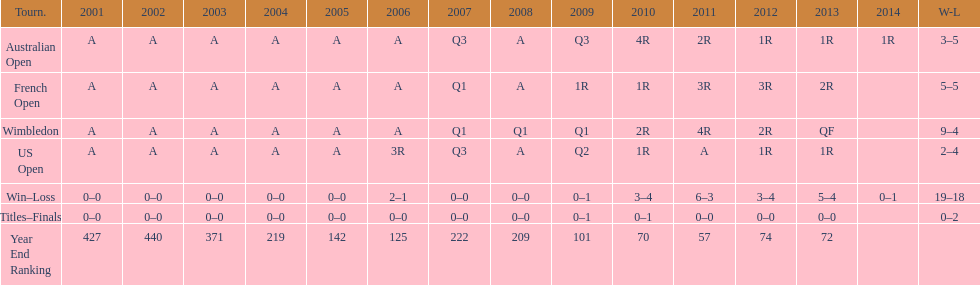In which years were there only 1 loss? 2006, 2009, 2014. Could you parse the entire table as a dict? {'header': ['Tourn.', '2001', '2002', '2003', '2004', '2005', '2006', '2007', '2008', '2009', '2010', '2011', '2012', '2013', '2014', 'W-L'], 'rows': [['Australian Open', 'A', 'A', 'A', 'A', 'A', 'A', 'Q3', 'A', 'Q3', '4R', '2R', '1R', '1R', '1R', '3–5'], ['French Open', 'A', 'A', 'A', 'A', 'A', 'A', 'Q1', 'A', '1R', '1R', '3R', '3R', '2R', '', '5–5'], ['Wimbledon', 'A', 'A', 'A', 'A', 'A', 'A', 'Q1', 'Q1', 'Q1', '2R', '4R', '2R', 'QF', '', '9–4'], ['US Open', 'A', 'A', 'A', 'A', 'A', '3R', 'Q3', 'A', 'Q2', '1R', 'A', '1R', '1R', '', '2–4'], ['Win–Loss', '0–0', '0–0', '0–0', '0–0', '0–0', '2–1', '0–0', '0–0', '0–1', '3–4', '6–3', '3–4', '5–4', '0–1', '19–18'], ['Titles–Finals', '0–0', '0–0', '0–0', '0–0', '0–0', '0–0', '0–0', '0–0', '0–1', '0–1', '0–0', '0–0', '0–0', '', '0–2'], ['Year End Ranking', '427', '440', '371', '219', '142', '125', '222', '209', '101', '70', '57', '74', '72', '', '']]} 